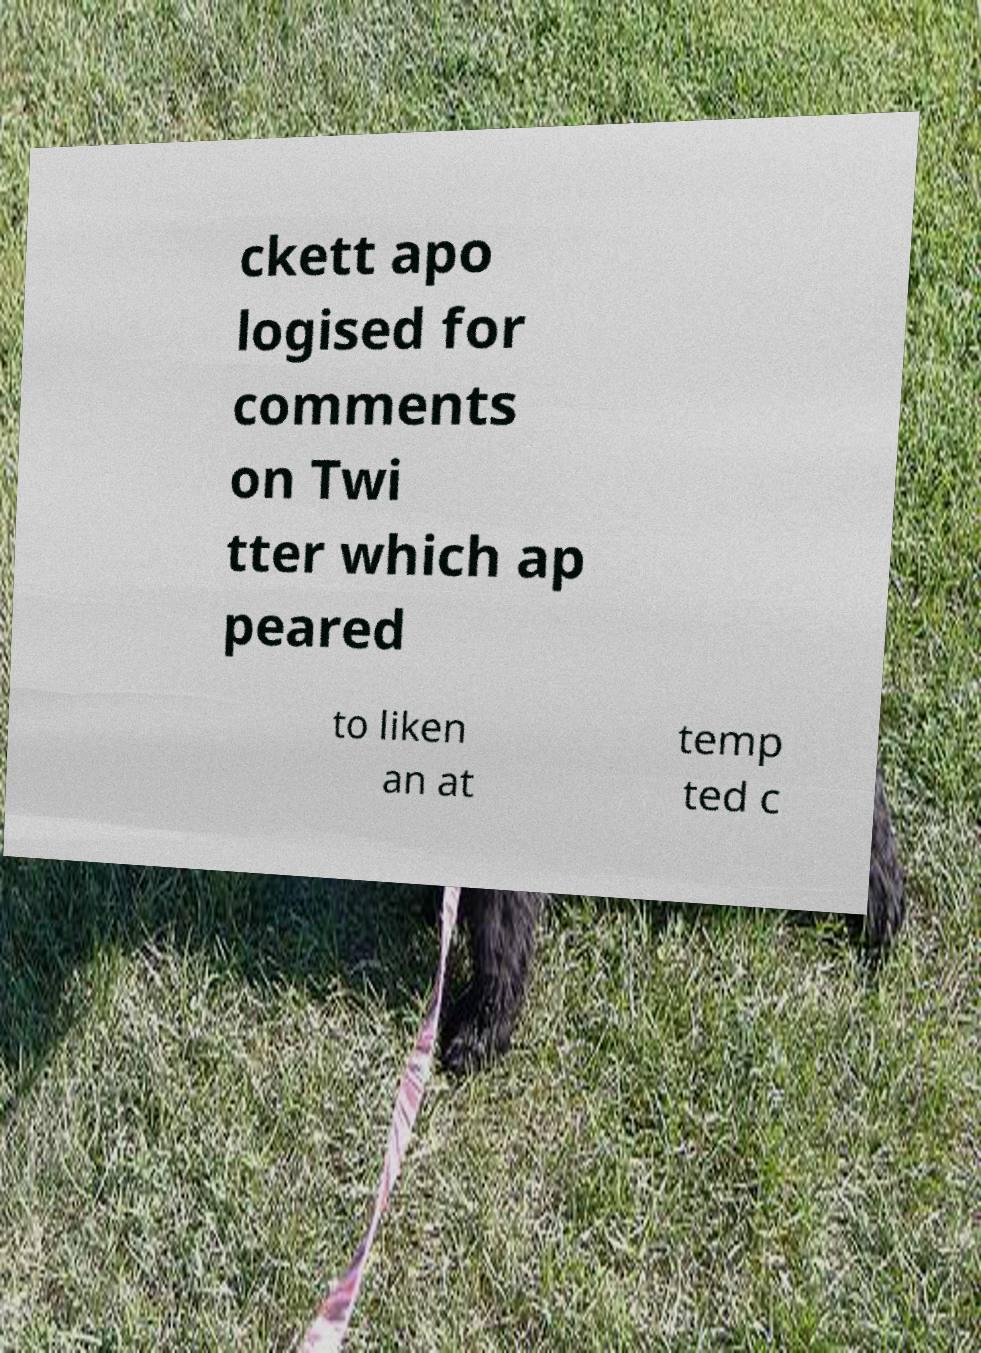There's text embedded in this image that I need extracted. Can you transcribe it verbatim? ckett apo logised for comments on Twi tter which ap peared to liken an at temp ted c 